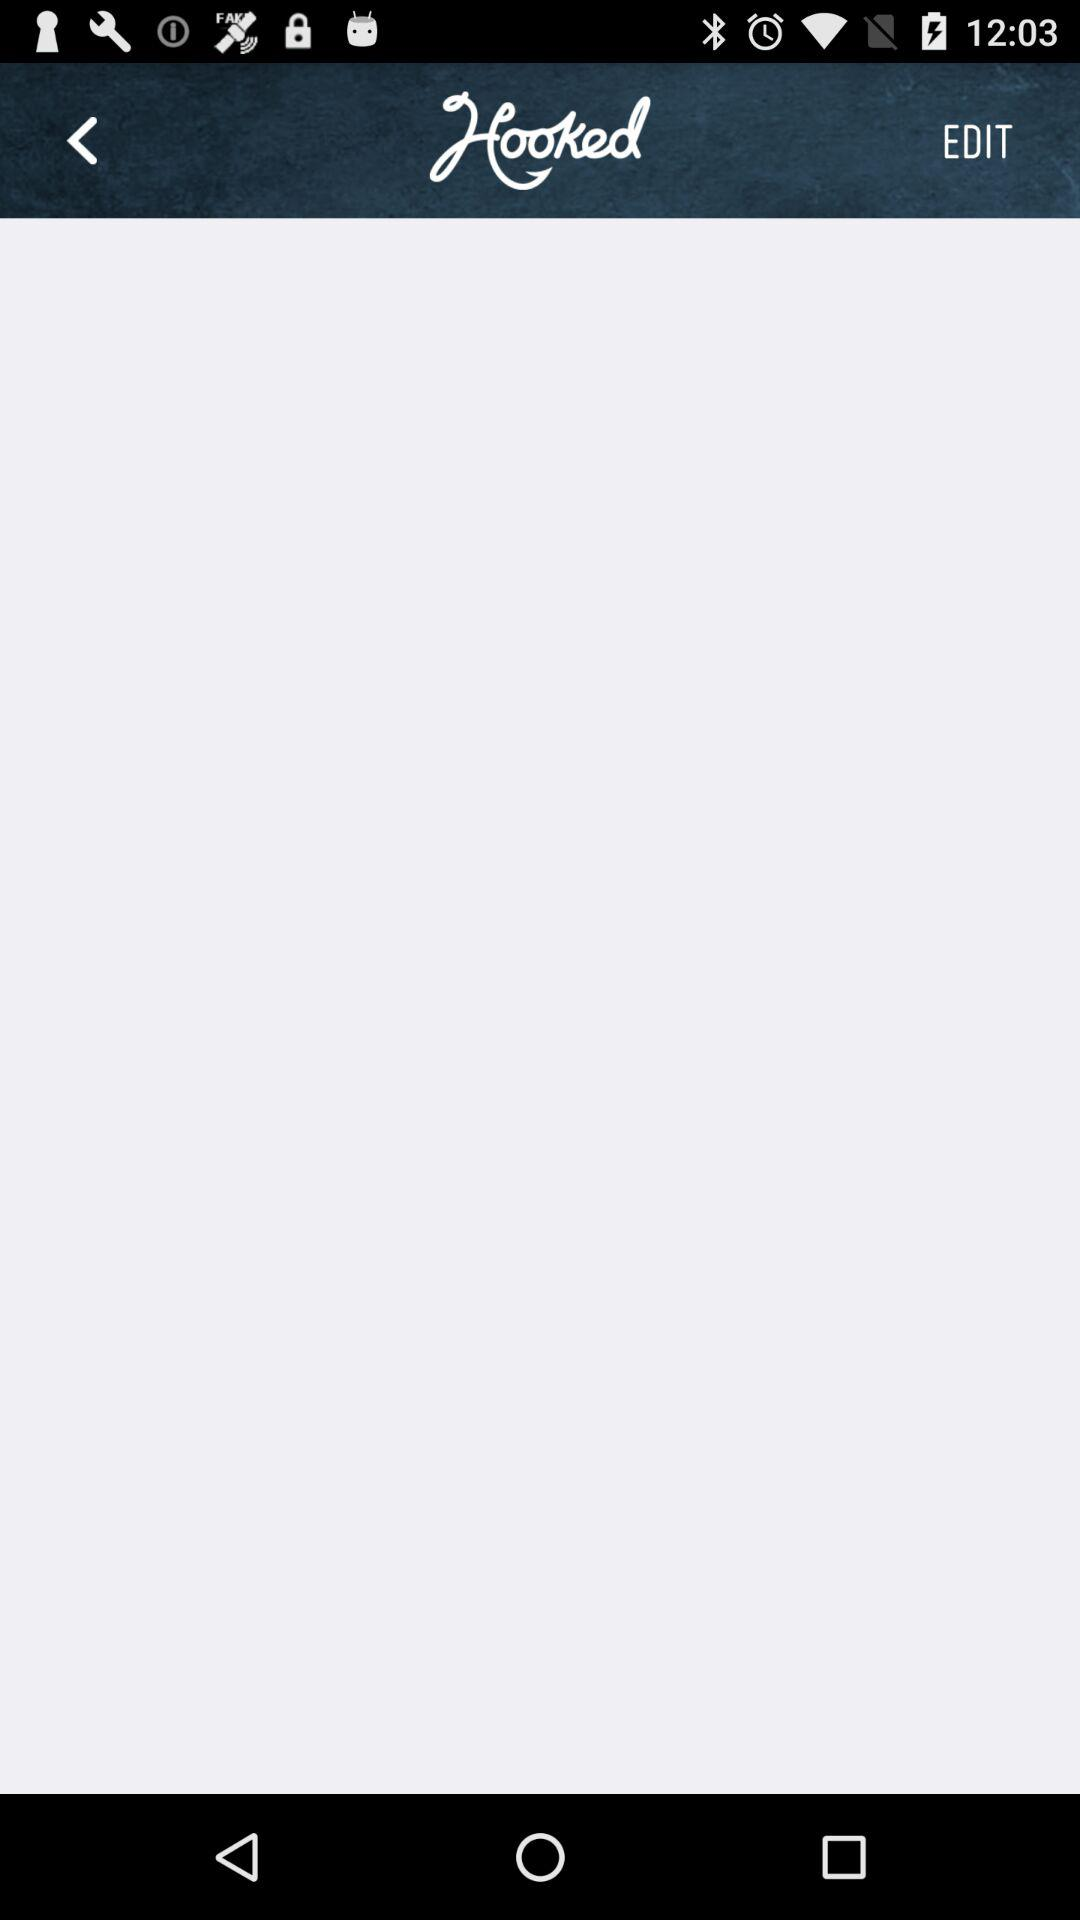What is the name of the application? The name of the application is "Hooked". 